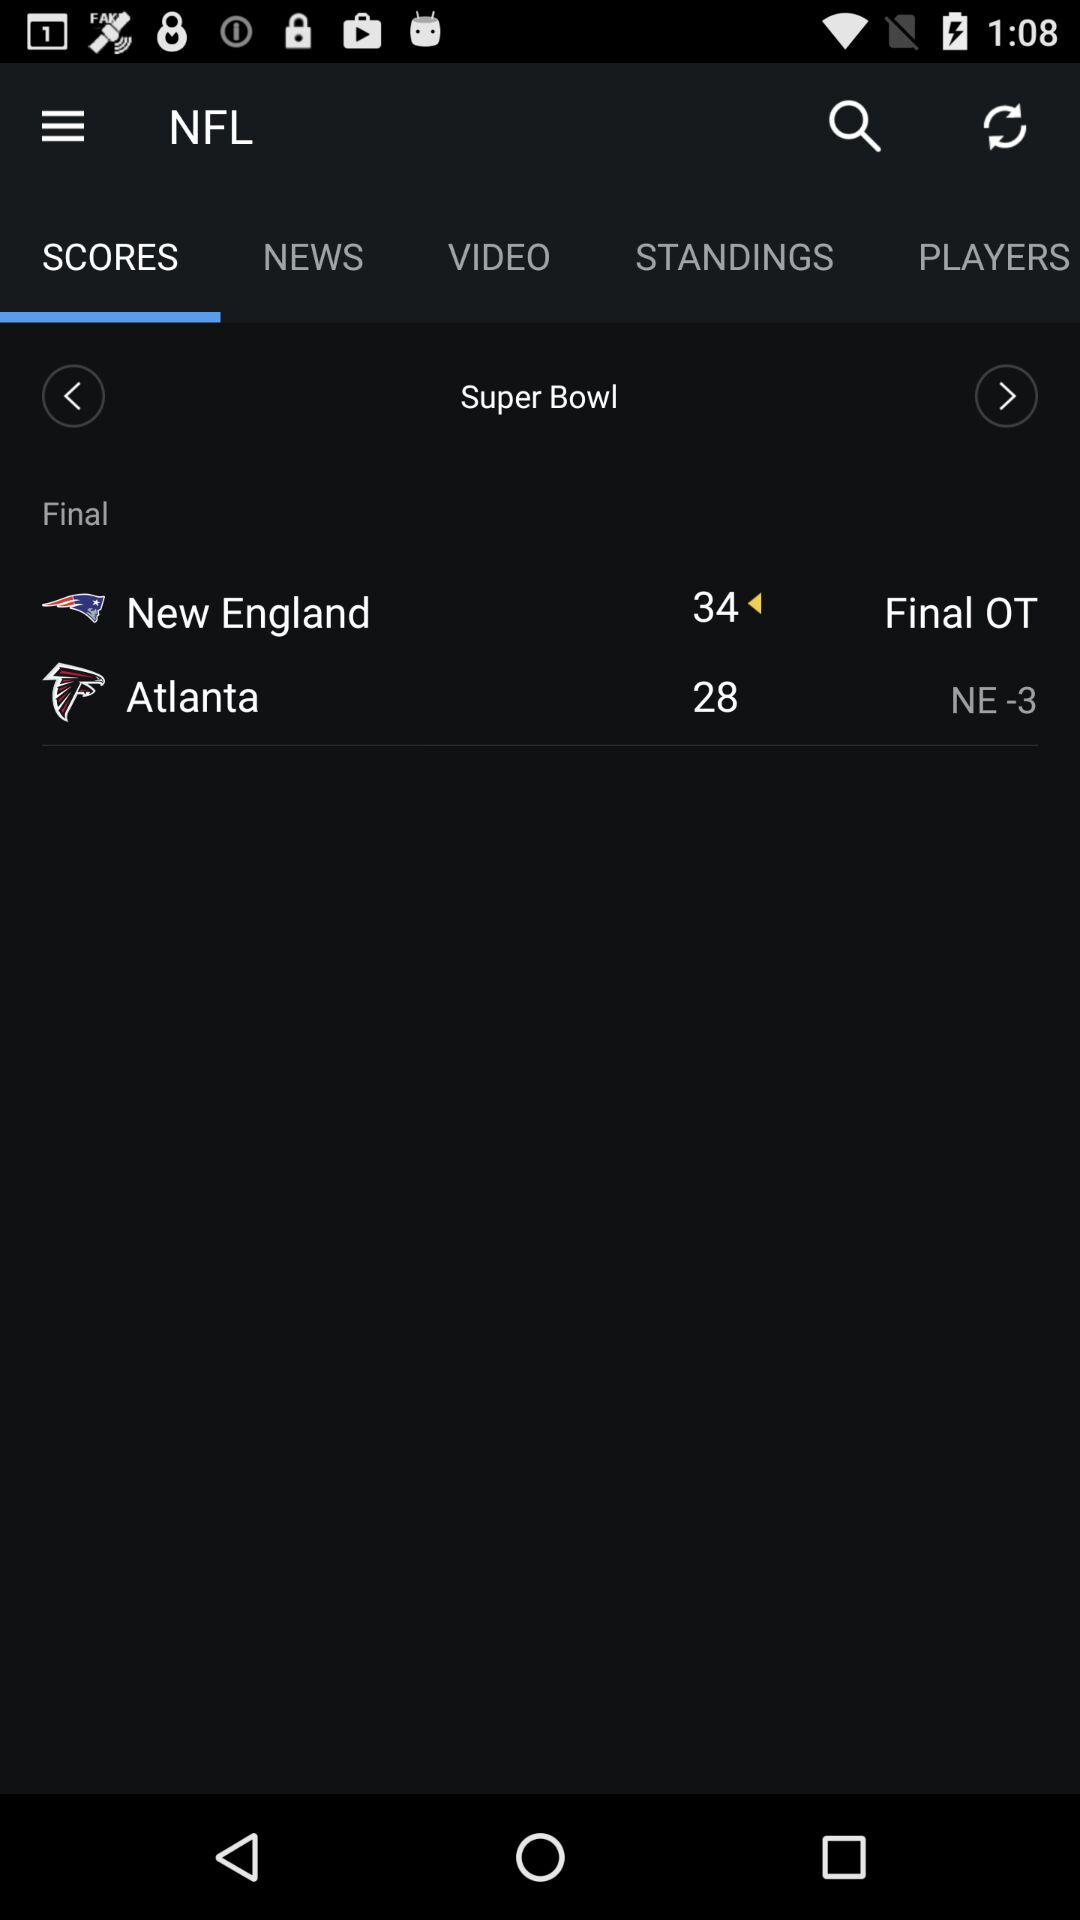What type of league is played between New England and Atlanta? The league played between New England and Atlanta is the " NFL". 